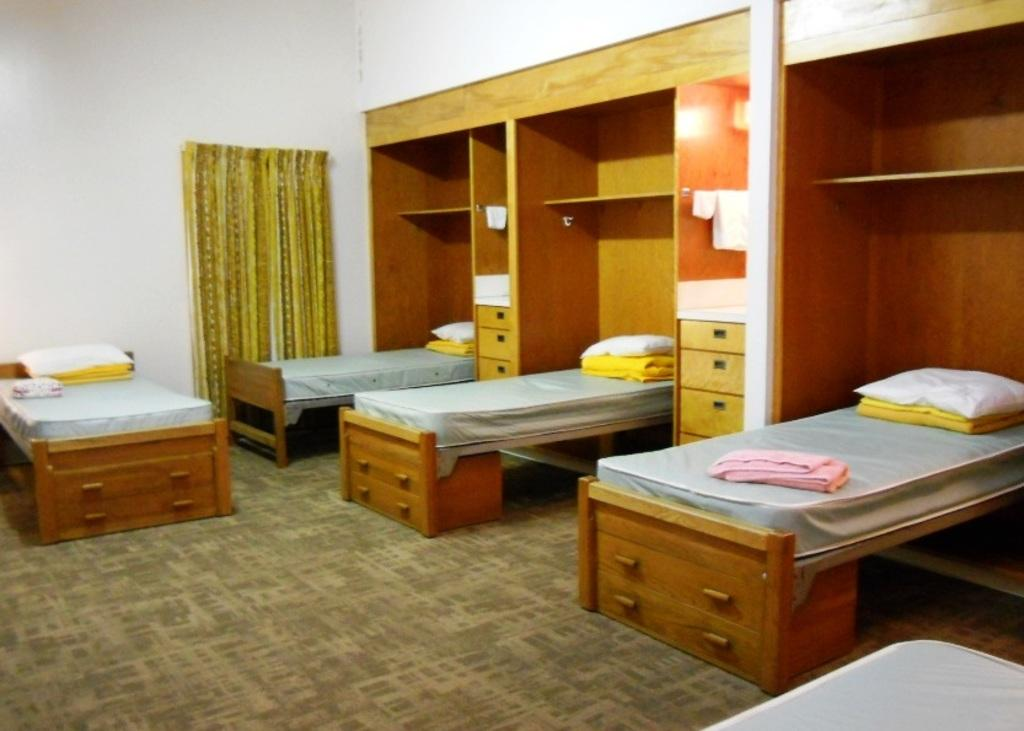How many beds are in the image? There are four beds in the image. What is placed on top of the beds? There are pillows on the beds. What can be seen on the floor in the image? The floor is visible in the image, and there is a carpet on the floor. What is in the background of the image? There is a wall in the background of the image. What is present in the image for covering or concealing? There is a curtain in the image. What is used for holding or storing items in the image? There is a rack in the image. What is the chance of milk being spilled on the carpet in the image? There is no indication of milk or any spillage in the image, so it's not possible to determine the chance of milk being spilled on the carpet. 